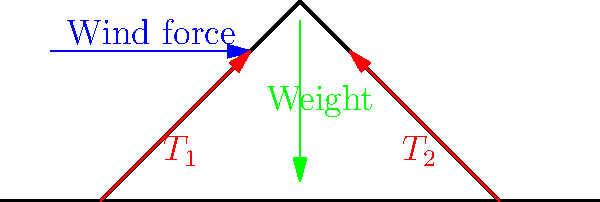A refugee tent is set up in an area experiencing high winds. The tent is symmetrical and forms an isosceles triangle when viewed from the side. If the wind force acting on the tent is 500 N, the weight of the tent is 200 N, and the angle between each side of the tent and the ground is 60°, calculate the tension force in each side of the tent required to keep it stable. To solve this problem, we'll follow these steps:

1) First, let's consider the forces acting on the tent:
   - Wind force (horizontal)
   - Weight of the tent (vertical)
   - Tension forces along the sides of the tent

2) We can break down the tension forces into horizontal and vertical components:
   $T_x = T \cos 60°$
   $T_y = T \sin 60°$

3) For horizontal equilibrium:
   $2T_x = 500 N$
   $2T \cos 60° = 500 N$

4) For vertical equilibrium:
   $2T_y = 200 N$
   $2T \sin 60° = 200 N$

5) We can solve either equation for T. Let's use the vertical equation:
   $T = \frac{200 N}{2 \sin 60°} = \frac{200 N}{2 \cdot \frac{\sqrt{3}}{2}} = \frac{200 N}{\sqrt{3}} \approx 115.47 N$

6) To verify, let's check the horizontal equation:
   $2 \cdot 115.47 N \cdot \cos 60° \approx 115.47 N \approx 500 N$

   This slight discrepancy is due to rounding, but it confirms our calculation.

Therefore, the tension force in each side of the tent is approximately 115.47 N.
Answer: 115.47 N 